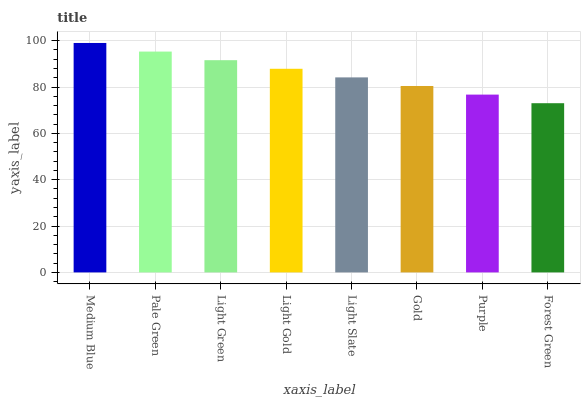Is Forest Green the minimum?
Answer yes or no. Yes. Is Medium Blue the maximum?
Answer yes or no. Yes. Is Pale Green the minimum?
Answer yes or no. No. Is Pale Green the maximum?
Answer yes or no. No. Is Medium Blue greater than Pale Green?
Answer yes or no. Yes. Is Pale Green less than Medium Blue?
Answer yes or no. Yes. Is Pale Green greater than Medium Blue?
Answer yes or no. No. Is Medium Blue less than Pale Green?
Answer yes or no. No. Is Light Gold the high median?
Answer yes or no. Yes. Is Light Slate the low median?
Answer yes or no. Yes. Is Gold the high median?
Answer yes or no. No. Is Forest Green the low median?
Answer yes or no. No. 